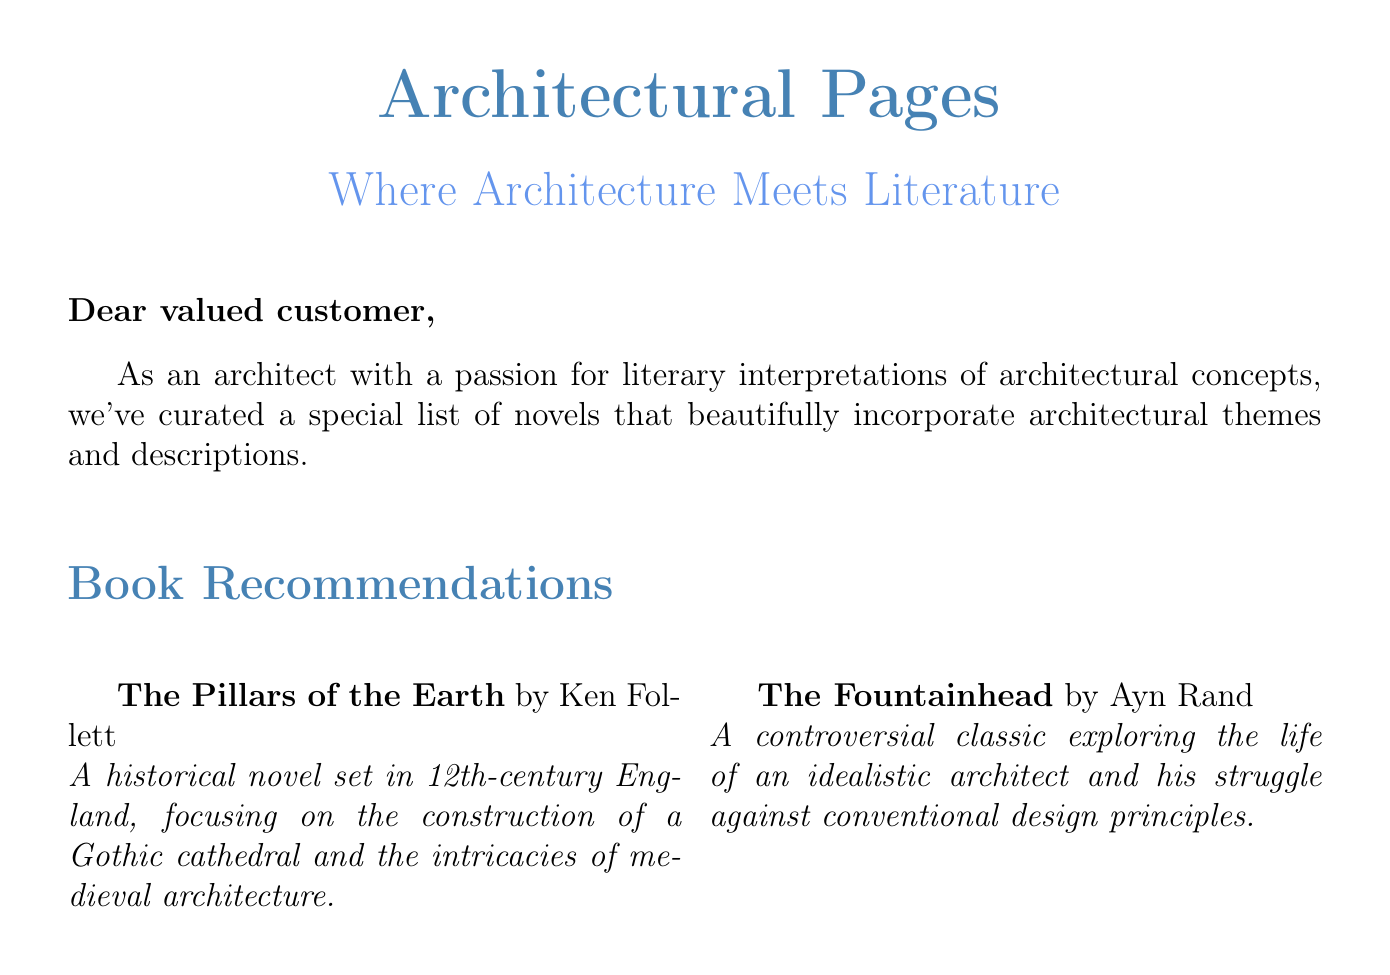What is the name of the bookstore? The bookstore is referred to as "Architectural Pages" in the document.
Answer: Architectural Pages Who is the author of "The Fountainhead"? The document specifies that "The Fountainhead" is authored by Ayn Rand.
Answer: Ayn Rand What is the main architectural focus of "The Pillars of the Earth"? The focus of "The Pillars of the Earth" is on the construction of a Gothic cathedral.
Answer: Gothic cathedral How many books are recommended in total? The document lists four books in the recommendations section.
Answer: Four Which novel intertwines architecture with a serial killer's tale? The document states that "The Devil in the White City" combines the story of architecture with a serial killer's narrative.
Answer: The Devil in the White City What time period is "The Pillars of the Earth" set in? The document notes that "The Pillars of the Earth" takes place in 12th-century England.
Answer: 12th-century What theme is explored in "The Fountainhead"? The document notes the theme of struggle against conventional design principles in "The Fountainhead."
Answer: Conventional design principles What is the conclusion of the document? The conclusion expresses hope that the selections provide new perspectives on literature and architecture.
Answer: New perspectives on literature and architecture Who curated the book recommendations? The document indicates that the Architectural Pages team curated the recommendations.
Answer: Architectural Pages Team 